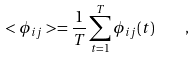Convert formula to latex. <formula><loc_0><loc_0><loc_500><loc_500>< \phi _ { i j } > = \frac { 1 } { T } \sum _ { t = 1 } ^ { T } \phi _ { i j } ( t ) \quad ,</formula> 